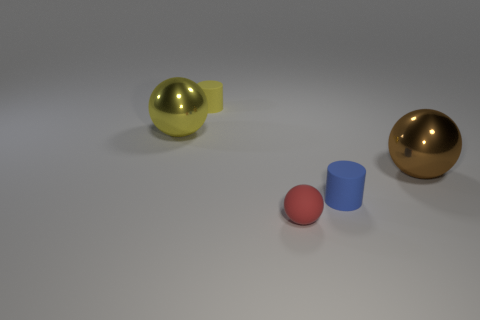There is a blue matte object that is the same size as the red matte ball; what shape is it?
Offer a terse response. Cylinder. How many things are both on the right side of the yellow sphere and on the left side of the small red thing?
Give a very brief answer. 1. Is the number of yellow shiny spheres that are in front of the tiny blue matte object less than the number of large yellow things?
Offer a very short reply. Yes. Are there any other yellow shiny spheres of the same size as the yellow metallic ball?
Give a very brief answer. No. What color is the big sphere that is made of the same material as the big brown object?
Provide a succinct answer. Yellow. There is a shiny thing that is to the left of the rubber sphere; how many brown metallic balls are on the right side of it?
Offer a very short reply. 1. There is a thing that is in front of the large yellow shiny sphere and behind the blue matte thing; what is its material?
Offer a very short reply. Metal. Do the shiny thing on the right side of the yellow rubber object and the large yellow thing have the same shape?
Provide a succinct answer. Yes. Are there fewer big red shiny objects than shiny things?
Your response must be concise. Yes. How many tiny matte things are the same color as the tiny ball?
Your response must be concise. 0. 